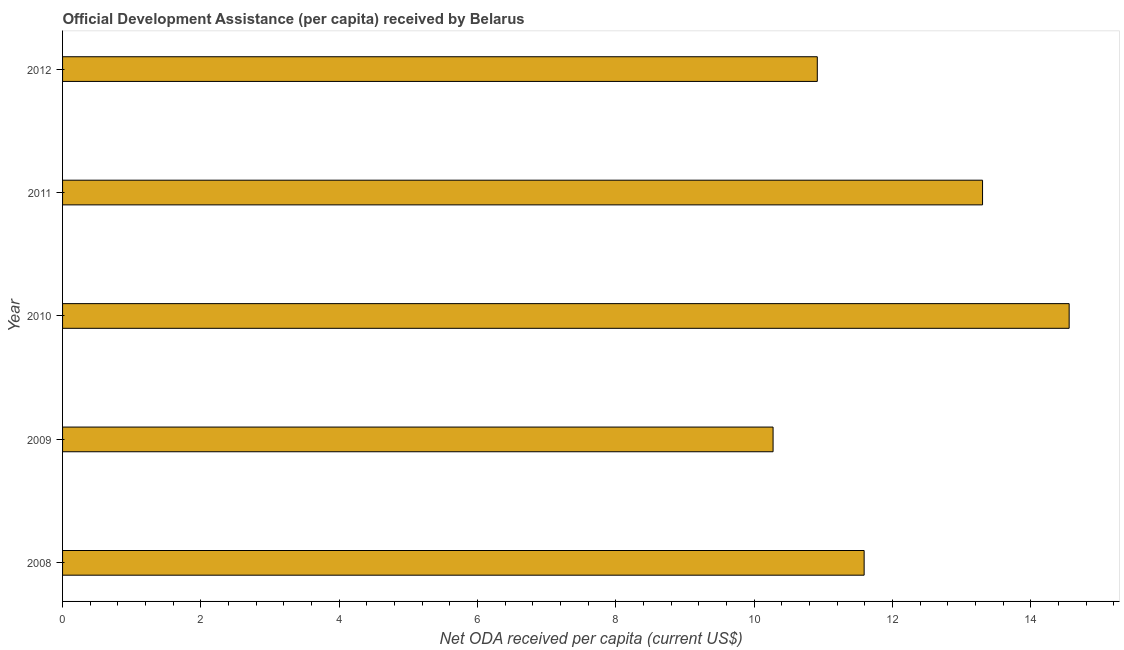Does the graph contain grids?
Give a very brief answer. No. What is the title of the graph?
Ensure brevity in your answer.  Official Development Assistance (per capita) received by Belarus. What is the label or title of the X-axis?
Offer a terse response. Net ODA received per capita (current US$). What is the label or title of the Y-axis?
Provide a succinct answer. Year. What is the net oda received per capita in 2008?
Provide a succinct answer. 11.59. Across all years, what is the maximum net oda received per capita?
Your answer should be compact. 14.55. Across all years, what is the minimum net oda received per capita?
Provide a succinct answer. 10.27. What is the sum of the net oda received per capita?
Provide a short and direct response. 60.63. What is the difference between the net oda received per capita in 2011 and 2012?
Give a very brief answer. 2.39. What is the average net oda received per capita per year?
Offer a very short reply. 12.12. What is the median net oda received per capita?
Your response must be concise. 11.59. In how many years, is the net oda received per capita greater than 9.6 US$?
Ensure brevity in your answer.  5. Do a majority of the years between 2011 and 2010 (inclusive) have net oda received per capita greater than 13.6 US$?
Your response must be concise. No. What is the ratio of the net oda received per capita in 2009 to that in 2010?
Your answer should be very brief. 0.71. Is the net oda received per capita in 2008 less than that in 2010?
Offer a terse response. Yes. Is the difference between the net oda received per capita in 2008 and 2011 greater than the difference between any two years?
Make the answer very short. No. What is the difference between the highest and the second highest net oda received per capita?
Make the answer very short. 1.25. Is the sum of the net oda received per capita in 2009 and 2012 greater than the maximum net oda received per capita across all years?
Provide a succinct answer. Yes. What is the difference between the highest and the lowest net oda received per capita?
Offer a terse response. 4.28. How many bars are there?
Provide a succinct answer. 5. How many years are there in the graph?
Give a very brief answer. 5. What is the Net ODA received per capita (current US$) of 2008?
Offer a very short reply. 11.59. What is the Net ODA received per capita (current US$) of 2009?
Provide a succinct answer. 10.27. What is the Net ODA received per capita (current US$) of 2010?
Keep it short and to the point. 14.55. What is the Net ODA received per capita (current US$) of 2011?
Your answer should be compact. 13.3. What is the Net ODA received per capita (current US$) of 2012?
Your answer should be compact. 10.91. What is the difference between the Net ODA received per capita (current US$) in 2008 and 2009?
Your answer should be compact. 1.32. What is the difference between the Net ODA received per capita (current US$) in 2008 and 2010?
Your answer should be very brief. -2.96. What is the difference between the Net ODA received per capita (current US$) in 2008 and 2011?
Keep it short and to the point. -1.71. What is the difference between the Net ODA received per capita (current US$) in 2008 and 2012?
Provide a short and direct response. 0.68. What is the difference between the Net ODA received per capita (current US$) in 2009 and 2010?
Provide a succinct answer. -4.28. What is the difference between the Net ODA received per capita (current US$) in 2009 and 2011?
Provide a short and direct response. -3.03. What is the difference between the Net ODA received per capita (current US$) in 2009 and 2012?
Provide a succinct answer. -0.64. What is the difference between the Net ODA received per capita (current US$) in 2010 and 2011?
Make the answer very short. 1.25. What is the difference between the Net ODA received per capita (current US$) in 2010 and 2012?
Make the answer very short. 3.64. What is the difference between the Net ODA received per capita (current US$) in 2011 and 2012?
Your answer should be very brief. 2.39. What is the ratio of the Net ODA received per capita (current US$) in 2008 to that in 2009?
Offer a terse response. 1.13. What is the ratio of the Net ODA received per capita (current US$) in 2008 to that in 2010?
Ensure brevity in your answer.  0.8. What is the ratio of the Net ODA received per capita (current US$) in 2008 to that in 2011?
Offer a very short reply. 0.87. What is the ratio of the Net ODA received per capita (current US$) in 2008 to that in 2012?
Provide a succinct answer. 1.06. What is the ratio of the Net ODA received per capita (current US$) in 2009 to that in 2010?
Your response must be concise. 0.71. What is the ratio of the Net ODA received per capita (current US$) in 2009 to that in 2011?
Your answer should be very brief. 0.77. What is the ratio of the Net ODA received per capita (current US$) in 2009 to that in 2012?
Offer a terse response. 0.94. What is the ratio of the Net ODA received per capita (current US$) in 2010 to that in 2011?
Your answer should be compact. 1.09. What is the ratio of the Net ODA received per capita (current US$) in 2010 to that in 2012?
Give a very brief answer. 1.33. What is the ratio of the Net ODA received per capita (current US$) in 2011 to that in 2012?
Offer a terse response. 1.22. 